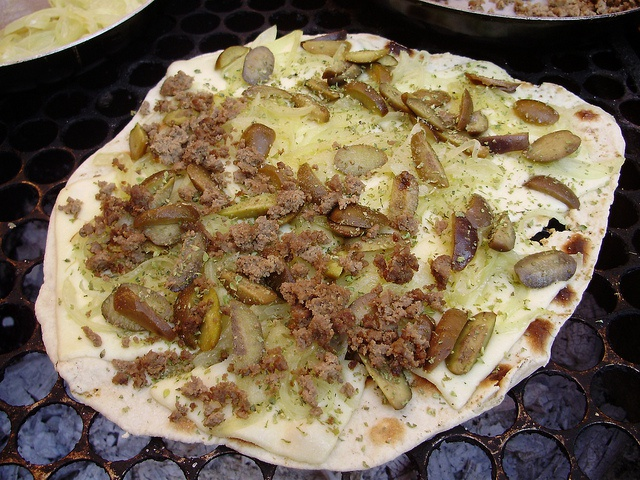Describe the objects in this image and their specific colors. I can see pizza in gray, tan, and olive tones, bowl in gray, black, darkgray, and maroon tones, and bowl in black and tan tones in this image. 